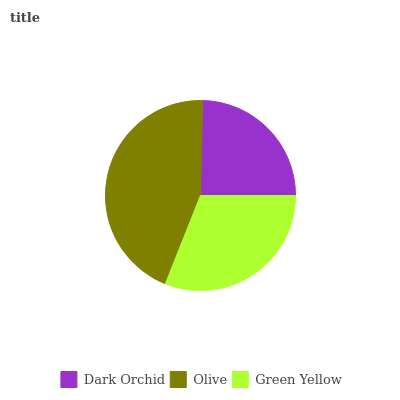Is Dark Orchid the minimum?
Answer yes or no. Yes. Is Olive the maximum?
Answer yes or no. Yes. Is Green Yellow the minimum?
Answer yes or no. No. Is Green Yellow the maximum?
Answer yes or no. No. Is Olive greater than Green Yellow?
Answer yes or no. Yes. Is Green Yellow less than Olive?
Answer yes or no. Yes. Is Green Yellow greater than Olive?
Answer yes or no. No. Is Olive less than Green Yellow?
Answer yes or no. No. Is Green Yellow the high median?
Answer yes or no. Yes. Is Green Yellow the low median?
Answer yes or no. Yes. Is Olive the high median?
Answer yes or no. No. Is Dark Orchid the low median?
Answer yes or no. No. 